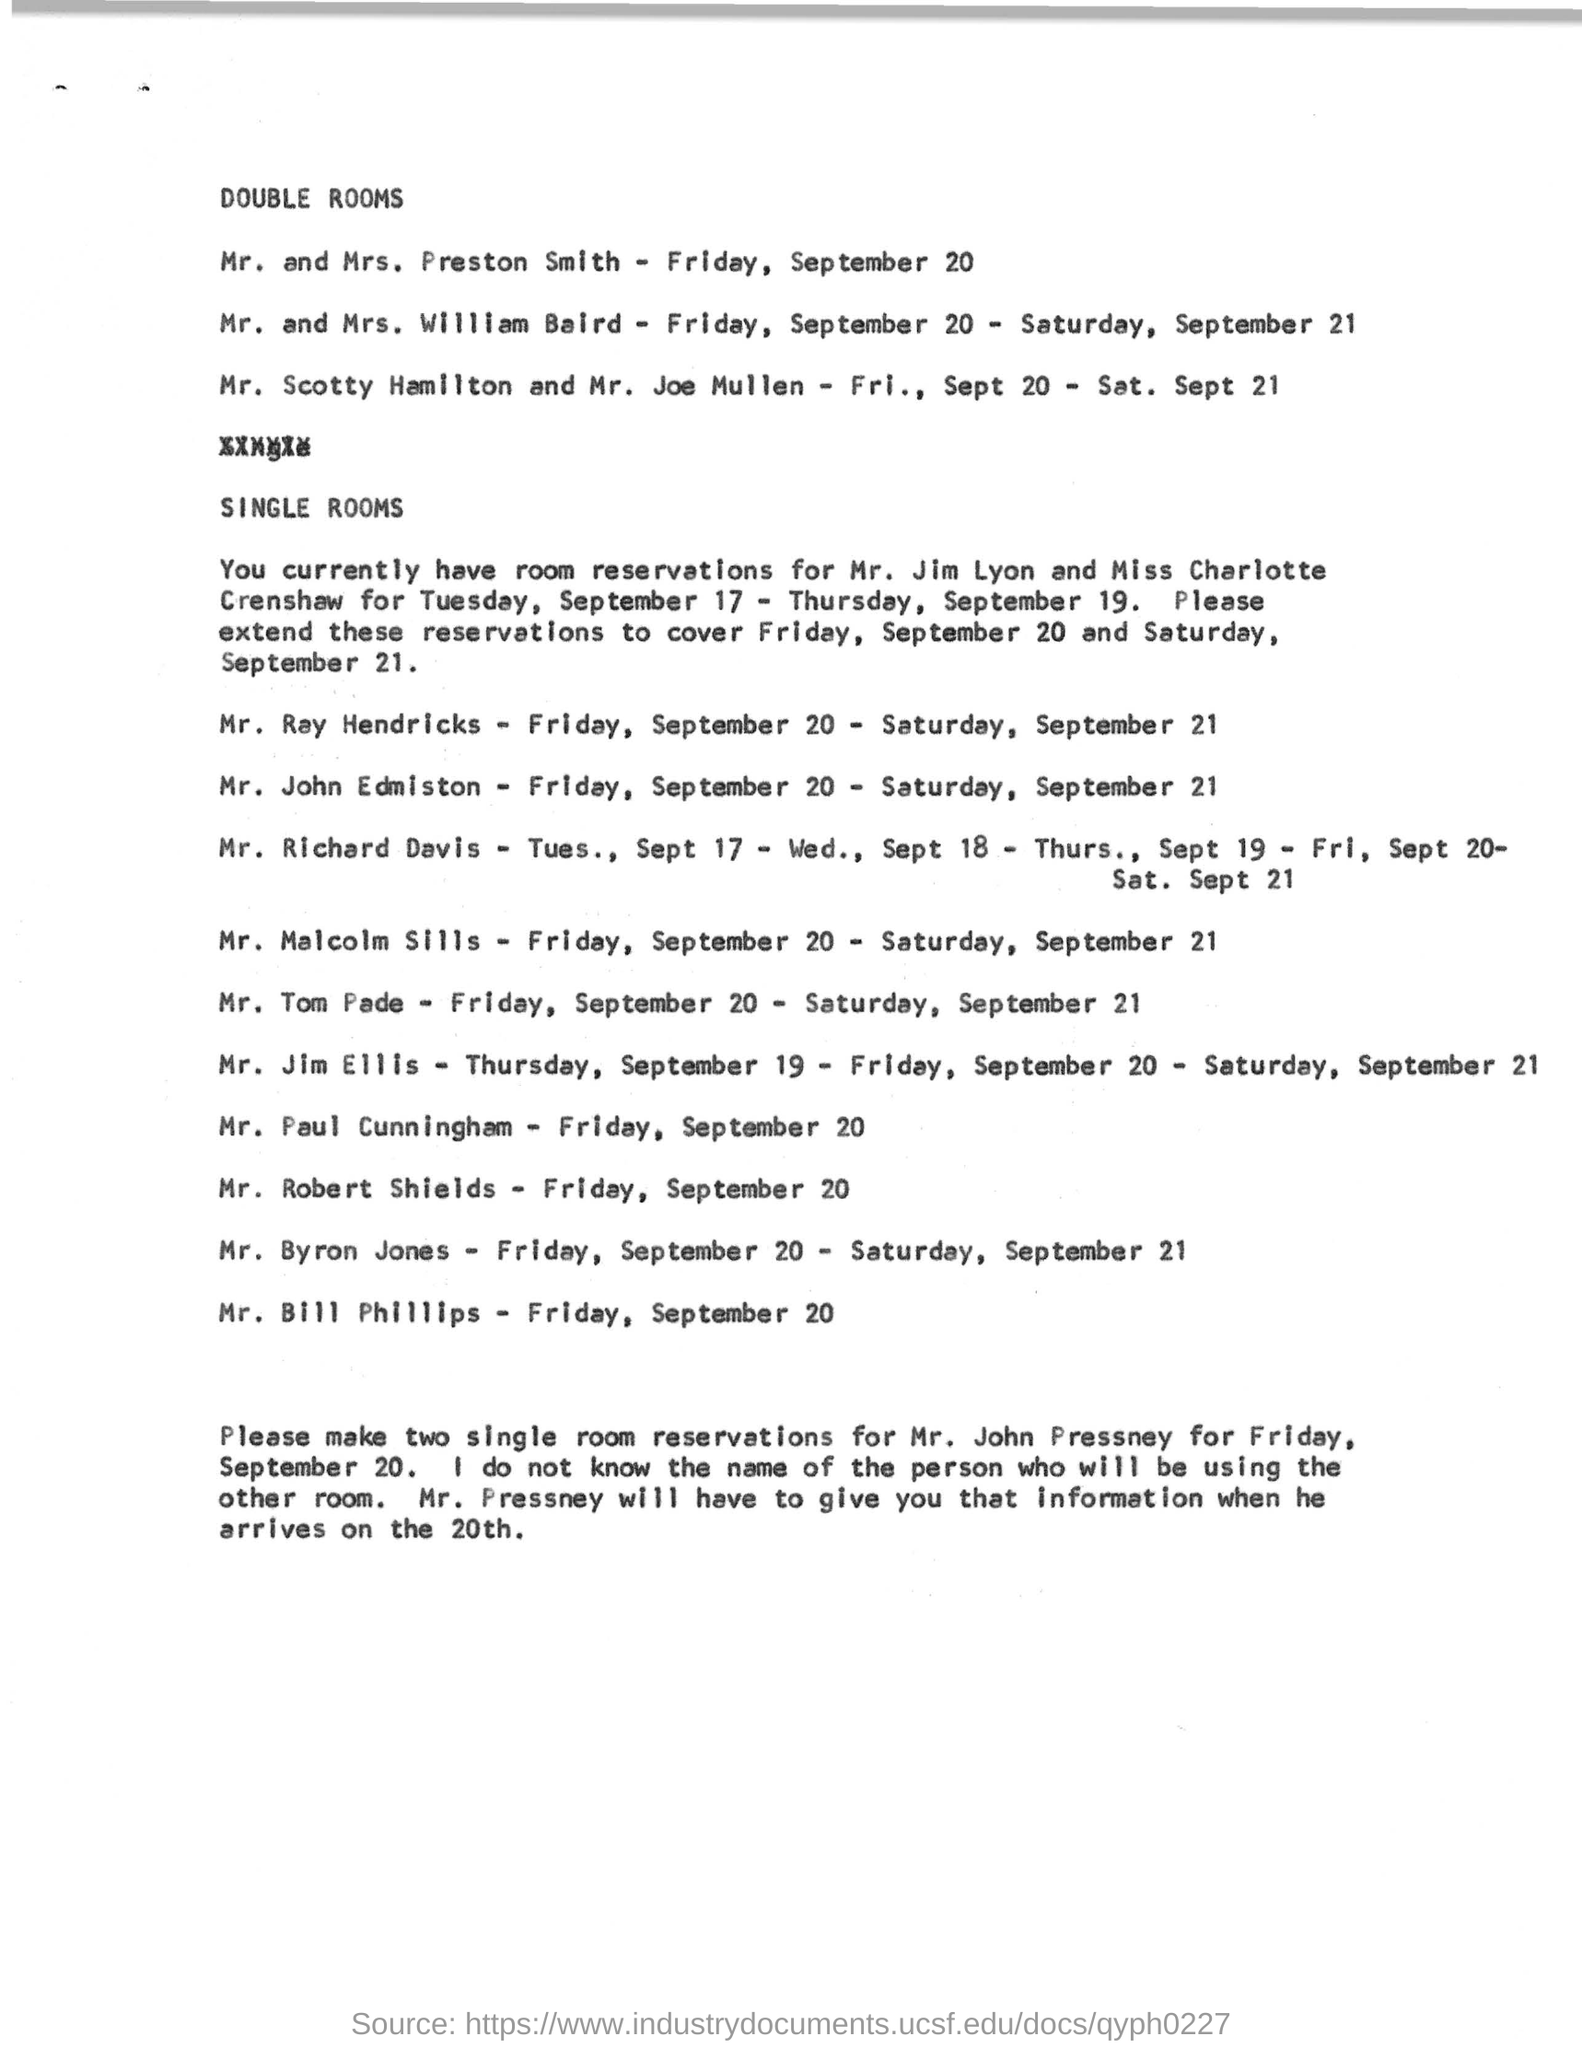Point out several critical features in this image. The current reservations are made for Mr. Jim Lyon and Miss Charlotte Crenshaw. On Friday, September 20, individuals are required to make single room reservations for Mr. John Pressney. On September 20th and 21st, Mr. Scotty Hamilton and Mr. Joe Mullen lived in a double room. On Friday, September 20, in double rooms, Mr. and Mrs. Preston Smith lived. 